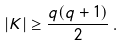<formula> <loc_0><loc_0><loc_500><loc_500>| K | \geq \frac { q ( q + 1 ) } { 2 } \, .</formula> 